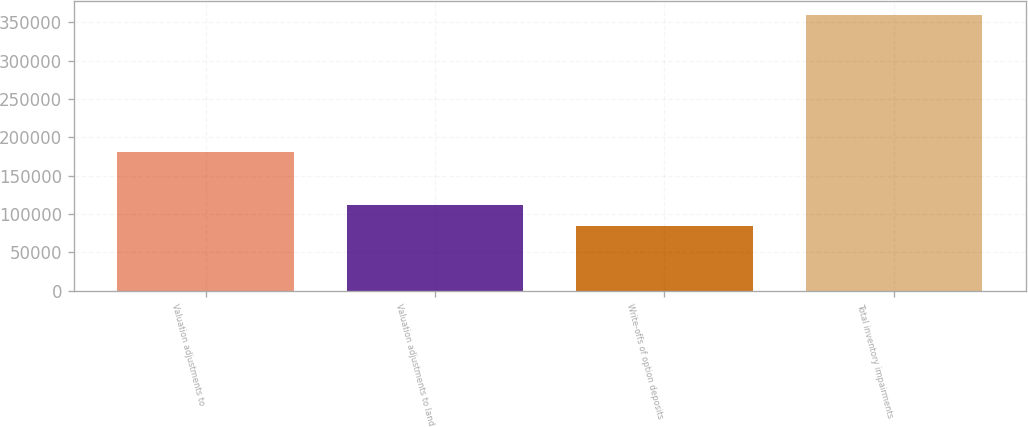<chart> <loc_0><loc_0><loc_500><loc_500><bar_chart><fcel>Valuation adjustments to<fcel>Valuation adjustments to land<fcel>Write-offs of option deposits<fcel>Total inventory impairments<nl><fcel>180239<fcel>111927<fcel>84372<fcel>359925<nl></chart> 